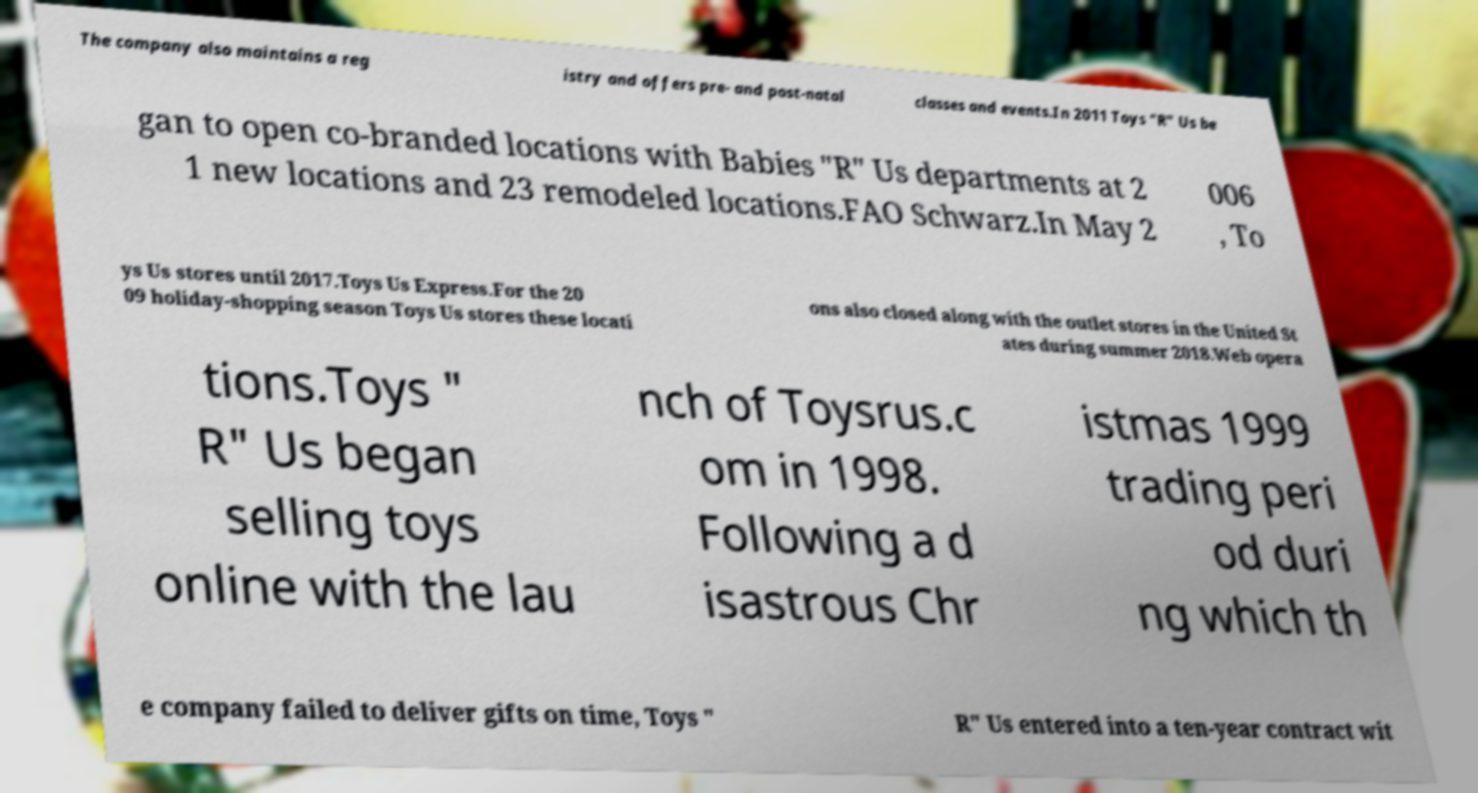Could you assist in decoding the text presented in this image and type it out clearly? The company also maintains a reg istry and offers pre- and post-natal classes and events.In 2011 Toys "R" Us be gan to open co-branded locations with Babies "R" Us departments at 2 1 new locations and 23 remodeled locations.FAO Schwarz.In May 2 006 , To ys Us stores until 2017.Toys Us Express.For the 20 09 holiday-shopping season Toys Us stores these locati ons also closed along with the outlet stores in the United St ates during summer 2018.Web opera tions.Toys " R" Us began selling toys online with the lau nch of Toysrus.c om in 1998. Following a d isastrous Chr istmas 1999 trading peri od duri ng which th e company failed to deliver gifts on time, Toys " R" Us entered into a ten-year contract wit 